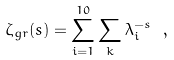Convert formula to latex. <formula><loc_0><loc_0><loc_500><loc_500>\zeta _ { g r } ( s ) = \sum ^ { 1 0 } _ { i = 1 } \sum _ { k } \lambda ^ { - s } _ { i } \ ,</formula> 